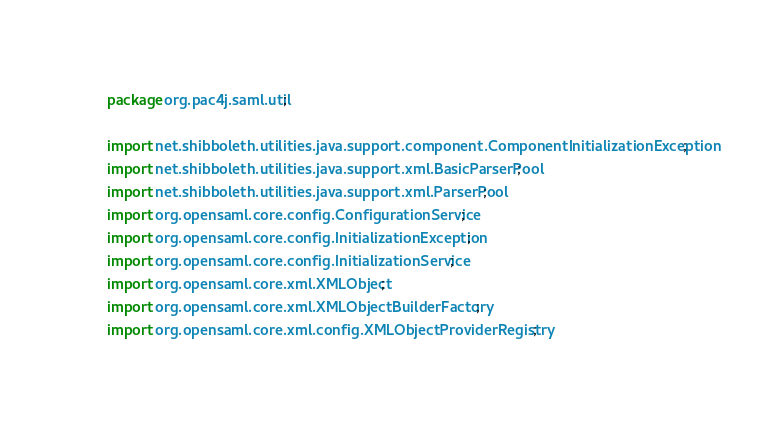<code> <loc_0><loc_0><loc_500><loc_500><_Java_>package org.pac4j.saml.util;

import net.shibboleth.utilities.java.support.component.ComponentInitializationException;
import net.shibboleth.utilities.java.support.xml.BasicParserPool;
import net.shibboleth.utilities.java.support.xml.ParserPool;
import org.opensaml.core.config.ConfigurationService;
import org.opensaml.core.config.InitializationException;
import org.opensaml.core.config.InitializationService;
import org.opensaml.core.xml.XMLObject;
import org.opensaml.core.xml.XMLObjectBuilderFactory;
import org.opensaml.core.xml.config.XMLObjectProviderRegistry;</code> 